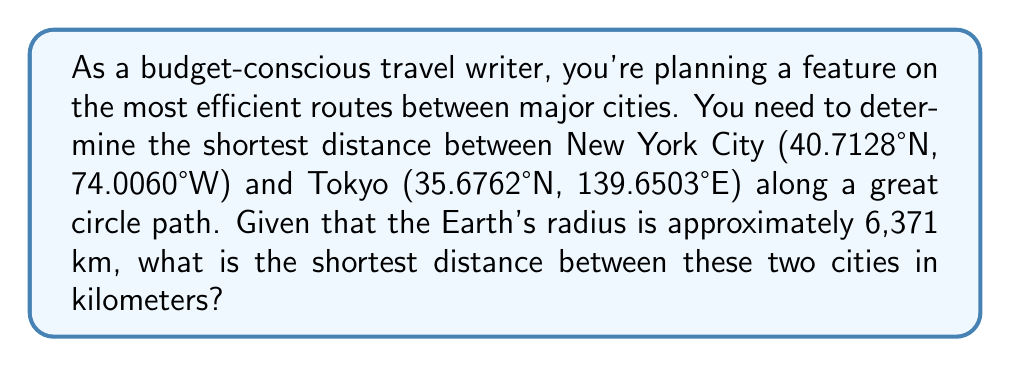Can you solve this math problem? To solve this problem, we'll use the great circle distance formula and follow these steps:

1. Convert the latitudes and longitudes to radians:
   $$\text{New York: } \phi_1 = 40.7128° \times \frac{\pi}{180} = 0.7101 \text{ rad}, \lambda_1 = -74.0060° \times \frac{\pi}{180} = -1.2915 \text{ rad}$$
   $$\text{Tokyo: } \phi_2 = 35.6762° \times \frac{\pi}{180} = 0.6226 \text{ rad}, \lambda_2 = 139.6503° \times \frac{\pi}{180} = 2.4372 \text{ rad}$$

2. Calculate the central angle $\Delta\sigma$ using the Haversine formula:
   $$\Delta\sigma = 2 \arcsin\left(\sqrt{\sin^2\left(\frac{\phi_2 - \phi_1}{2}\right) + \cos\phi_1 \cos\phi_2 \sin^2\left(\frac{\lambda_2 - \lambda_1}{2}\right)}\right)$$

3. Substitute the values:
   $$\Delta\sigma = 2 \arcsin\left(\sqrt{\sin^2\left(\frac{0.6226 - 0.7101}{2}\right) + \cos(0.7101) \cos(0.6226) \sin^2\left(\frac{2.4372 - (-1.2915)}{2}\right)}\right)$$

4. Evaluate the expression:
   $$\Delta\sigma = 2 \arcsin(\sqrt{0.0019 + 0.7456 \times 0.7799 \times 0.8995}) = 2 \arcsin(\sqrt{0.5245}) = 2 \times 0.9935 = 1.9870 \text{ rad}$$

5. Calculate the distance $d$ along the great circle:
   $$d = R \times \Delta\sigma = 6371 \text{ km} \times 1.9870 \text{ rad} = 12,658.94 \text{ km}$$

Therefore, the shortest distance between New York City and Tokyo along a great circle path is approximately 12,659 km.
Answer: 12,659 km 